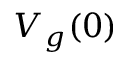<formula> <loc_0><loc_0><loc_500><loc_500>V _ { g } ( 0 )</formula> 